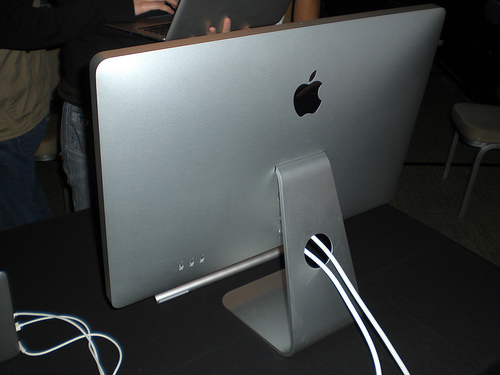<image>
Is the wire to the left of the computer? No. The wire is not to the left of the computer. From this viewpoint, they have a different horizontal relationship. 